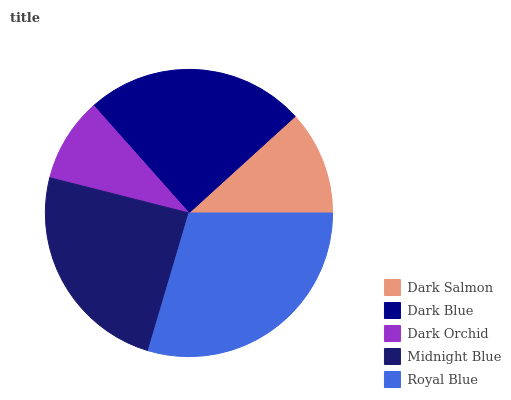Is Dark Orchid the minimum?
Answer yes or no. Yes. Is Royal Blue the maximum?
Answer yes or no. Yes. Is Dark Blue the minimum?
Answer yes or no. No. Is Dark Blue the maximum?
Answer yes or no. No. Is Dark Blue greater than Dark Salmon?
Answer yes or no. Yes. Is Dark Salmon less than Dark Blue?
Answer yes or no. Yes. Is Dark Salmon greater than Dark Blue?
Answer yes or no. No. Is Dark Blue less than Dark Salmon?
Answer yes or no. No. Is Midnight Blue the high median?
Answer yes or no. Yes. Is Midnight Blue the low median?
Answer yes or no. Yes. Is Dark Orchid the high median?
Answer yes or no. No. Is Dark Blue the low median?
Answer yes or no. No. 